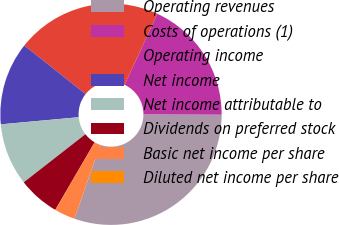Convert chart to OTSL. <chart><loc_0><loc_0><loc_500><loc_500><pie_chart><fcel>Operating revenues<fcel>Costs of operations (1)<fcel>Operating income<fcel>Net income<fcel>Net income attributable to<fcel>Dividends on preferred stock<fcel>Basic net income per share<fcel>Diluted net income per share<nl><fcel>30.3%<fcel>18.18%<fcel>21.21%<fcel>12.12%<fcel>9.09%<fcel>6.06%<fcel>3.03%<fcel>0.0%<nl></chart> 